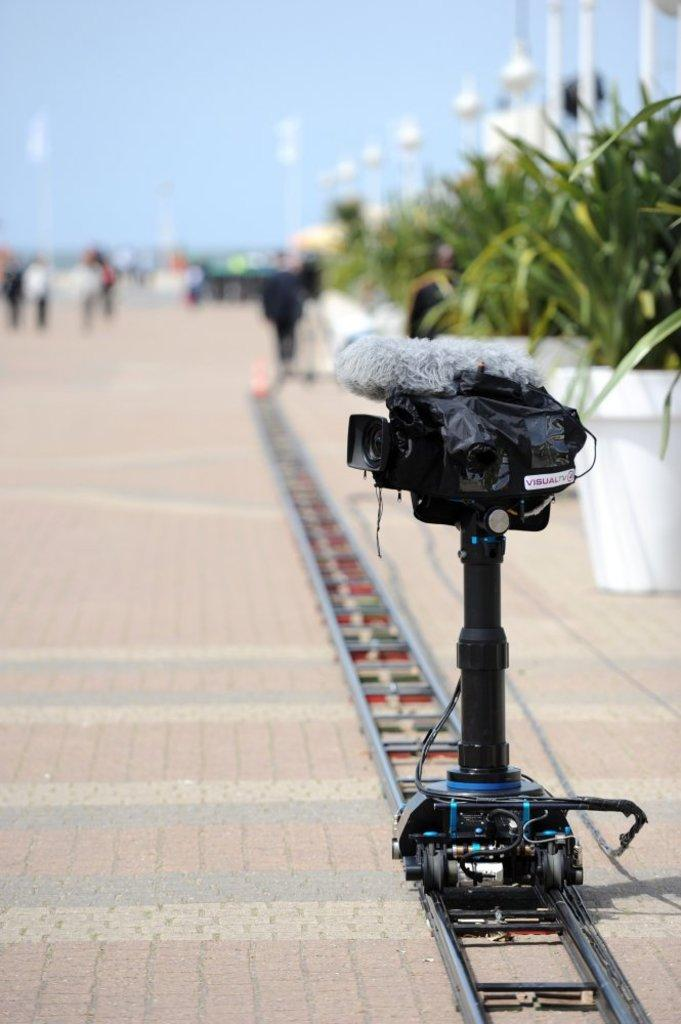What is the main subject of the image? The main subject of the image is a camera rolling on tracks. Where are the tracks located? The tracks are on a pavement. What else can be seen in the image besides the camera and tracks? There are people walking and plant pots in the image. What type of steel is used to construct the plot in the image? There is no plot or steel present in the image. The image features a camera rolling on tracks, people walking, and plant pots. 